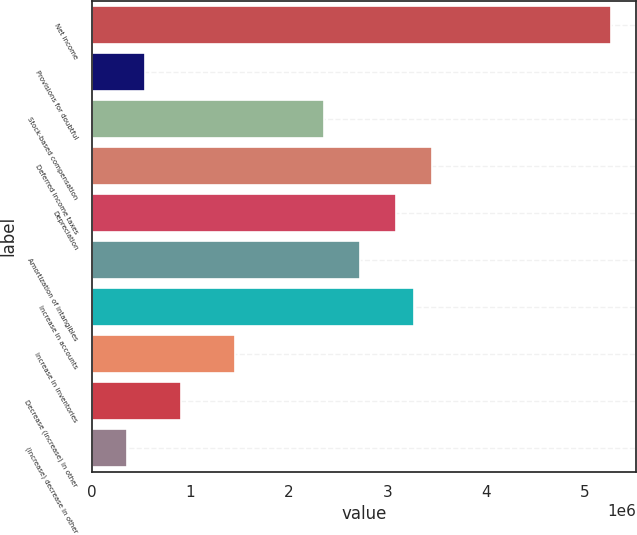Convert chart. <chart><loc_0><loc_0><loc_500><loc_500><bar_chart><fcel>Net income<fcel>Provisions for doubtful<fcel>Stock-based compensation<fcel>Deferred income taxes<fcel>Depreciation<fcel>Amortization of intangibles<fcel>Increase in accounts<fcel>Increase in inventories<fcel>Decrease (increase) in other<fcel>(Increase) decrease in other<nl><fcel>5.26542e+06<fcel>545144<fcel>2.36064e+06<fcel>3.44993e+06<fcel>3.08683e+06<fcel>2.72373e+06<fcel>3.26838e+06<fcel>1.45289e+06<fcel>908242<fcel>363595<nl></chart> 